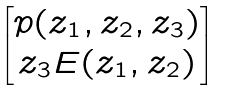Convert formula to latex. <formula><loc_0><loc_0><loc_500><loc_500>\begin{bmatrix} p ( z _ { 1 } , z _ { 2 } , z _ { 3 } ) \\ z _ { 3 } E ( z _ { 1 } , z _ { 2 } ) \end{bmatrix}</formula> 